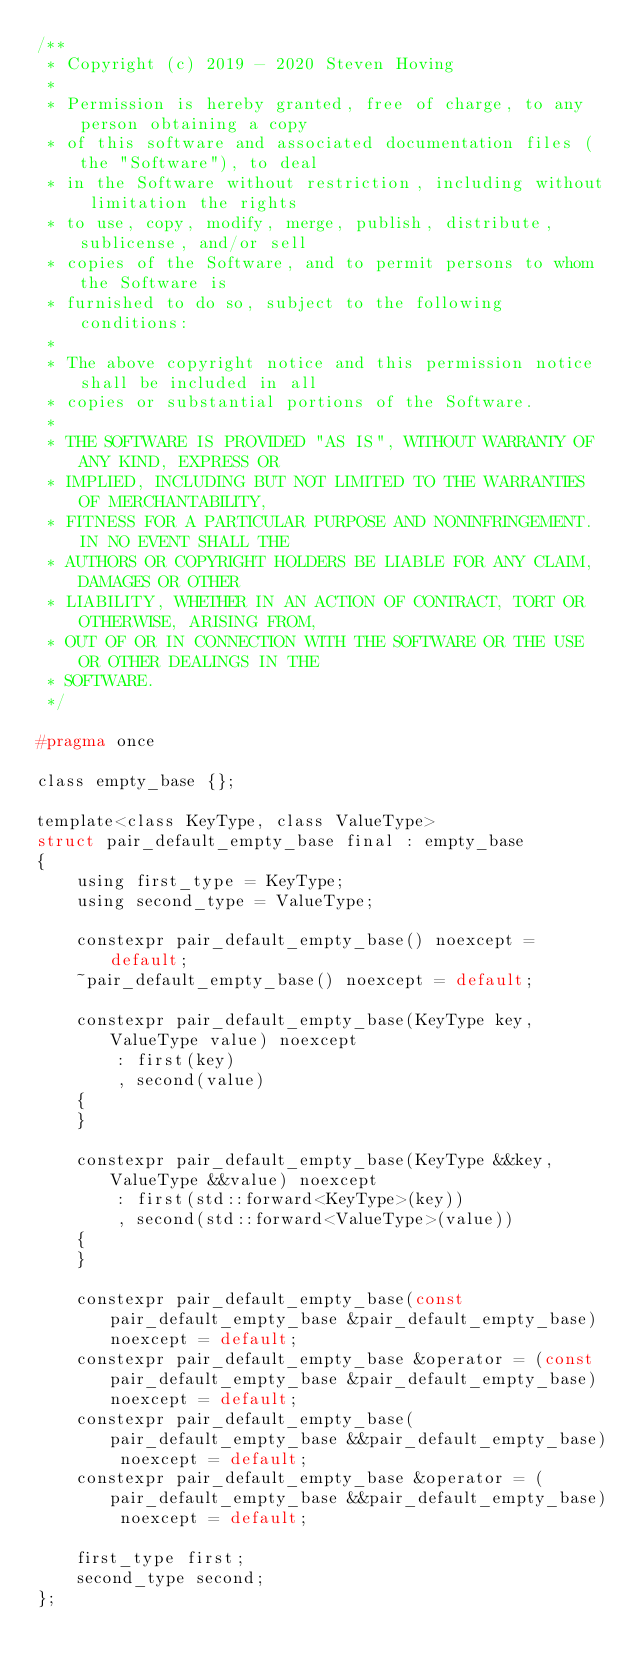<code> <loc_0><loc_0><loc_500><loc_500><_C_>/**
 * Copyright (c) 2019 - 2020 Steven Hoving
 *
 * Permission is hereby granted, free of charge, to any person obtaining a copy
 * of this software and associated documentation files (the "Software"), to deal
 * in the Software without restriction, including without limitation the rights
 * to use, copy, modify, merge, publish, distribute, sublicense, and/or sell
 * copies of the Software, and to permit persons to whom the Software is
 * furnished to do so, subject to the following conditions:
 *
 * The above copyright notice and this permission notice shall be included in all
 * copies or substantial portions of the Software.
 *
 * THE SOFTWARE IS PROVIDED "AS IS", WITHOUT WARRANTY OF ANY KIND, EXPRESS OR
 * IMPLIED, INCLUDING BUT NOT LIMITED TO THE WARRANTIES OF MERCHANTABILITY,
 * FITNESS FOR A PARTICULAR PURPOSE AND NONINFRINGEMENT. IN NO EVENT SHALL THE
 * AUTHORS OR COPYRIGHT HOLDERS BE LIABLE FOR ANY CLAIM, DAMAGES OR OTHER
 * LIABILITY, WHETHER IN AN ACTION OF CONTRACT, TORT OR OTHERWISE, ARISING FROM,
 * OUT OF OR IN CONNECTION WITH THE SOFTWARE OR THE USE OR OTHER DEALINGS IN THE
 * SOFTWARE.
 */

#pragma once

class empty_base {};

template<class KeyType, class ValueType>
struct pair_default_empty_base final : empty_base
{
    using first_type = KeyType;
    using second_type = ValueType;

    constexpr pair_default_empty_base() noexcept = default;
    ~pair_default_empty_base() noexcept = default;

    constexpr pair_default_empty_base(KeyType key, ValueType value) noexcept
        : first(key)
        , second(value)
    {
    }

    constexpr pair_default_empty_base(KeyType &&key, ValueType &&value) noexcept
        : first(std::forward<KeyType>(key))
        , second(std::forward<ValueType>(value))
    {
    }

    constexpr pair_default_empty_base(const pair_default_empty_base &pair_default_empty_base) noexcept = default;
    constexpr pair_default_empty_base &operator = (const pair_default_empty_base &pair_default_empty_base) noexcept = default;
    constexpr pair_default_empty_base(pair_default_empty_base &&pair_default_empty_base) noexcept = default;
    constexpr pair_default_empty_base &operator = (pair_default_empty_base &&pair_default_empty_base) noexcept = default;

    first_type first;
    second_type second;
};
</code> 